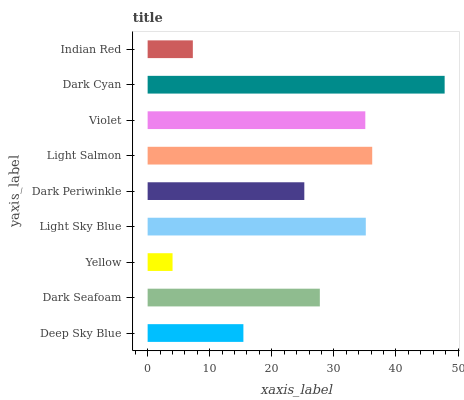Is Yellow the minimum?
Answer yes or no. Yes. Is Dark Cyan the maximum?
Answer yes or no. Yes. Is Dark Seafoam the minimum?
Answer yes or no. No. Is Dark Seafoam the maximum?
Answer yes or no. No. Is Dark Seafoam greater than Deep Sky Blue?
Answer yes or no. Yes. Is Deep Sky Blue less than Dark Seafoam?
Answer yes or no. Yes. Is Deep Sky Blue greater than Dark Seafoam?
Answer yes or no. No. Is Dark Seafoam less than Deep Sky Blue?
Answer yes or no. No. Is Dark Seafoam the high median?
Answer yes or no. Yes. Is Dark Seafoam the low median?
Answer yes or no. Yes. Is Light Salmon the high median?
Answer yes or no. No. Is Dark Cyan the low median?
Answer yes or no. No. 